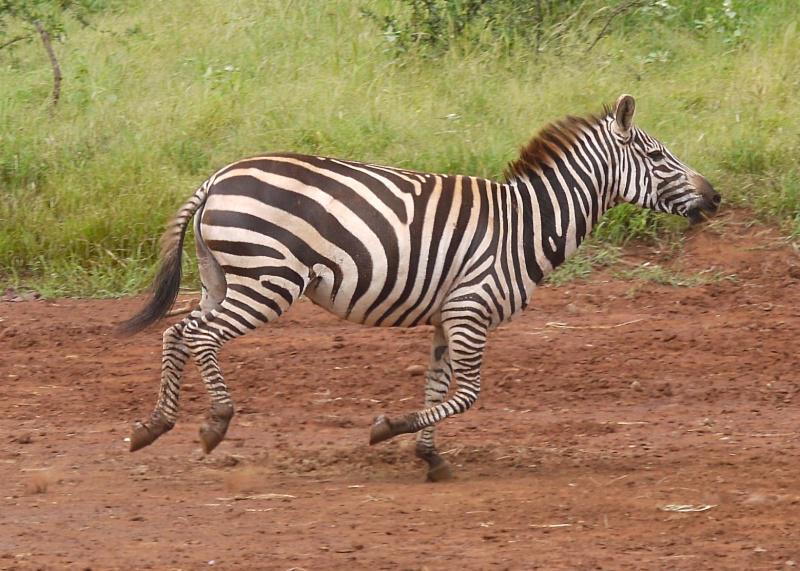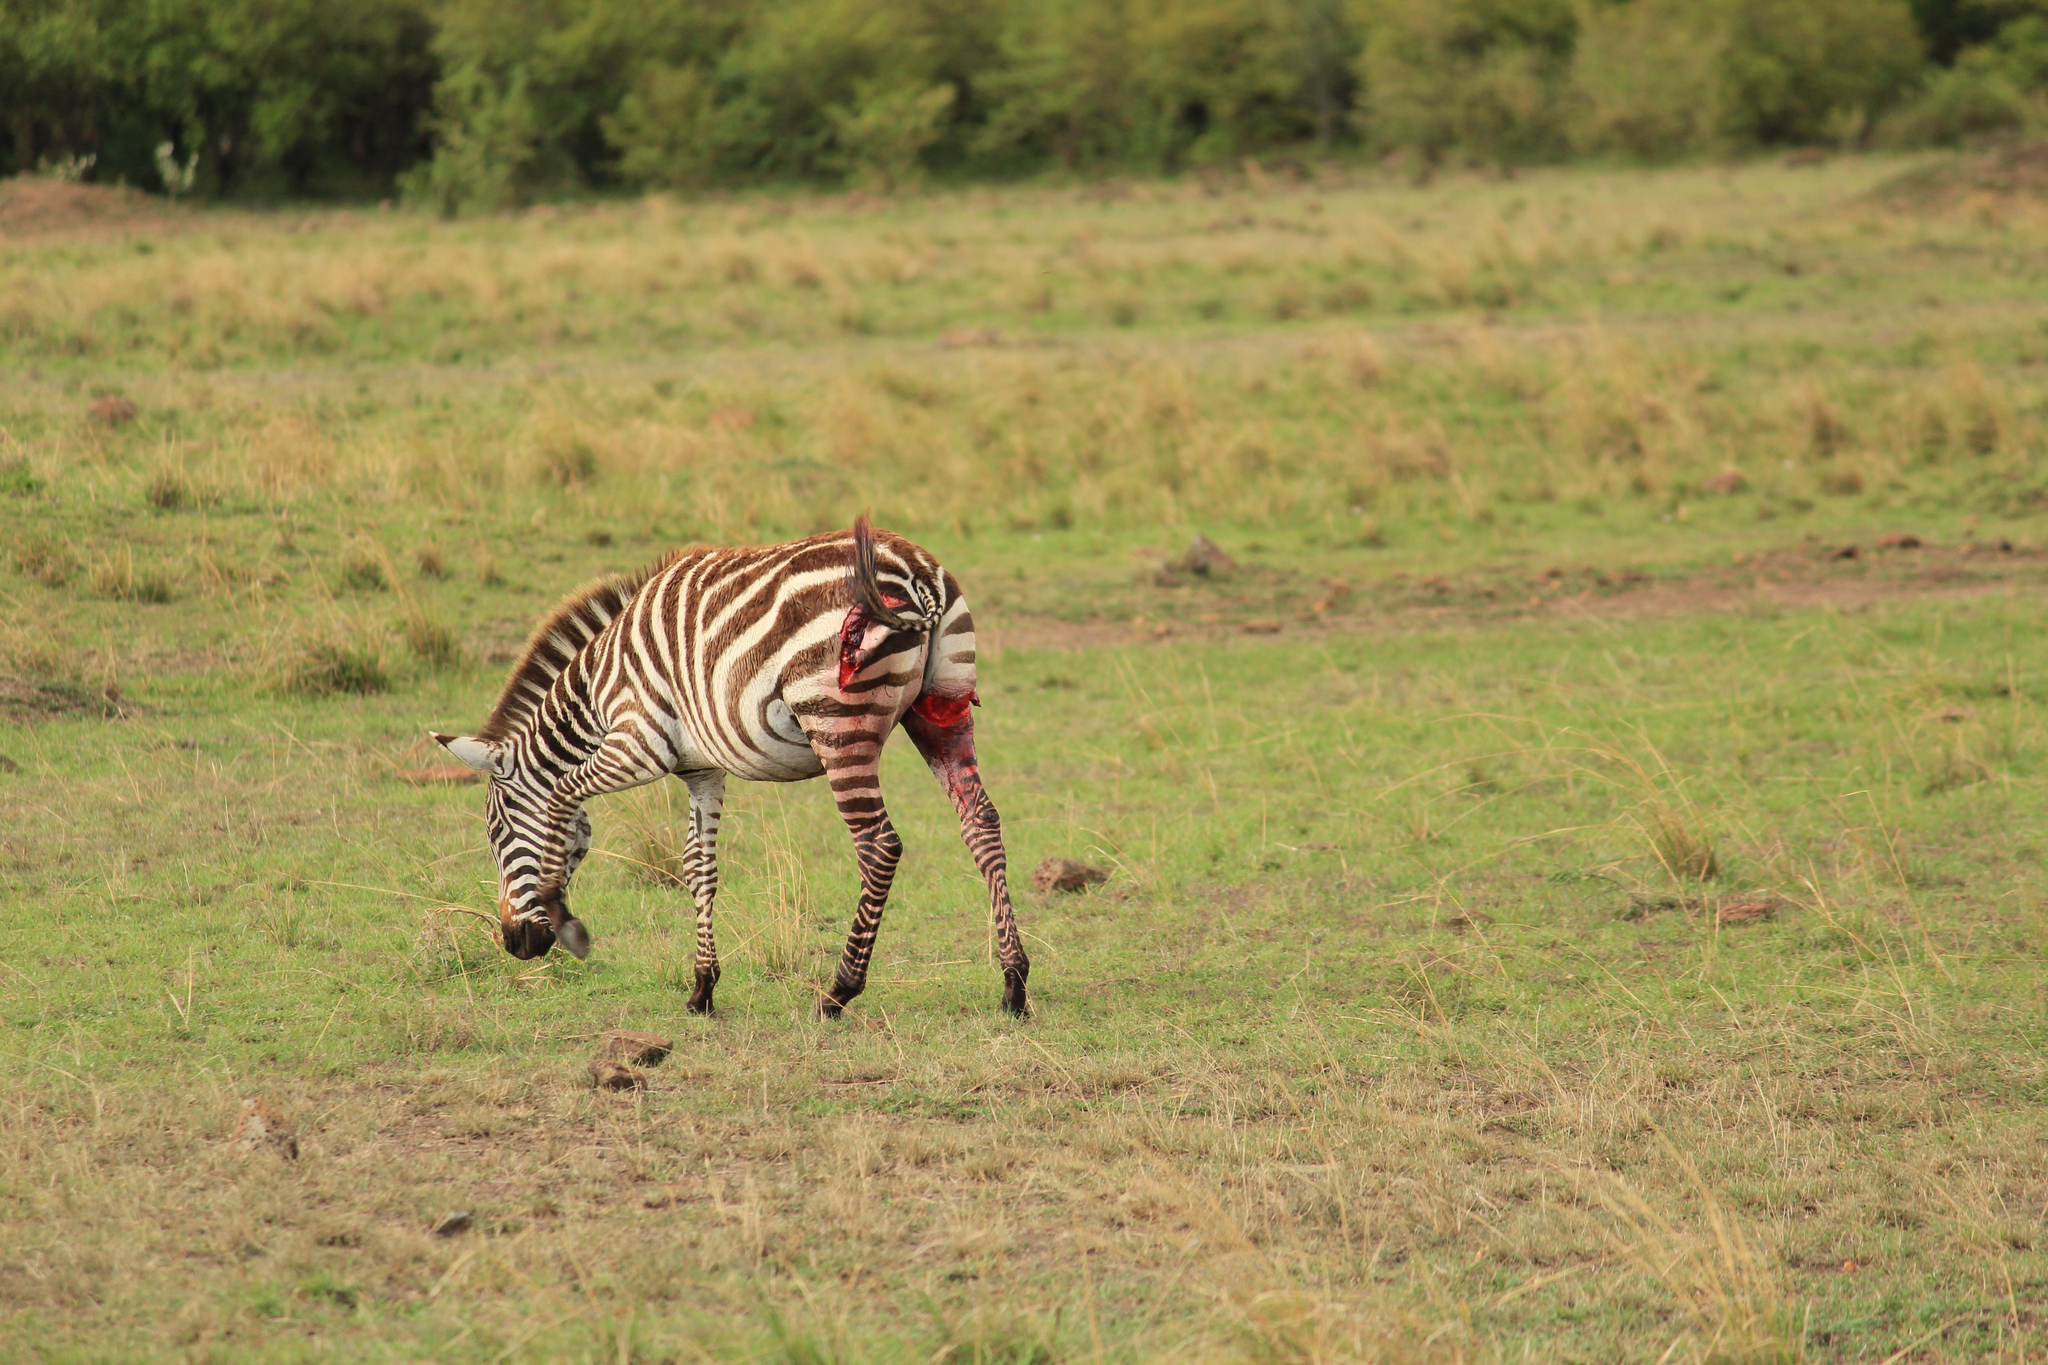The first image is the image on the left, the second image is the image on the right. Examine the images to the left and right. Is the description "The right image contains one zebras being attacked by a lion." accurate? Answer yes or no. No. The first image is the image on the left, the second image is the image on the right. Given the left and right images, does the statement "The right image shows a lion attacking from the back end of a zebra, with clouds of dust created by the struggle." hold true? Answer yes or no. No. 